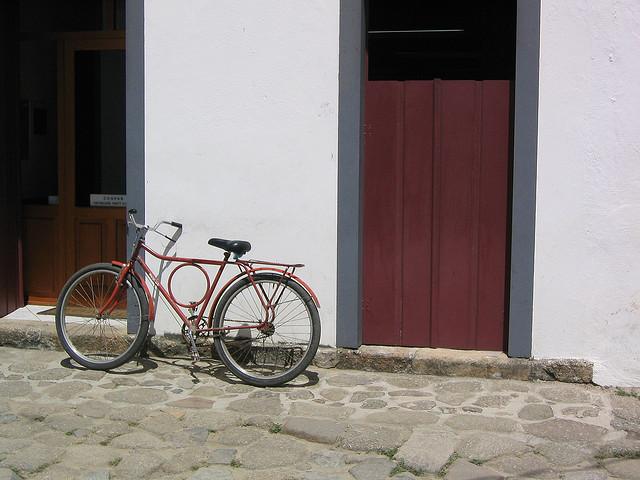What is the street made of?
Concise answer only. Stone. What is the color of the door frame?
Quick response, please. Gray. Is this a modern bike?
Quick response, please. No. Is the door open?
Quick response, please. No. What color are the doors?
Answer briefly. Red. Is the bicycle seat higher than the handlebars?
Give a very brief answer. No. 